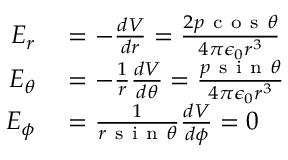Convert formula to latex. <formula><loc_0><loc_0><loc_500><loc_500>\begin{array} { r l } { E _ { r } } & = - \frac { d V } { d r } = \frac { 2 p c o s \theta } { 4 \pi \epsilon _ { 0 } r ^ { 3 } } } \\ { E _ { \theta } } & = - \frac { 1 } { r } \frac { d V } { d \theta } = \frac { p s i n \theta } { 4 \pi \epsilon _ { 0 } r ^ { 3 } } } \\ { E _ { \phi } } & = \frac { 1 } { r s i n \theta } \frac { d V } { d \phi } = 0 } \end{array}</formula> 